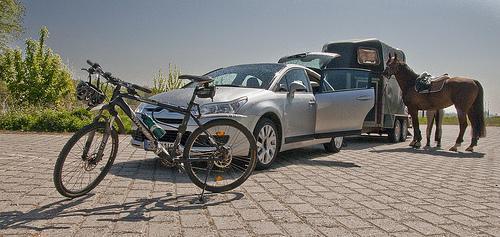How many animals are in this photo?
Give a very brief answer. 1. 